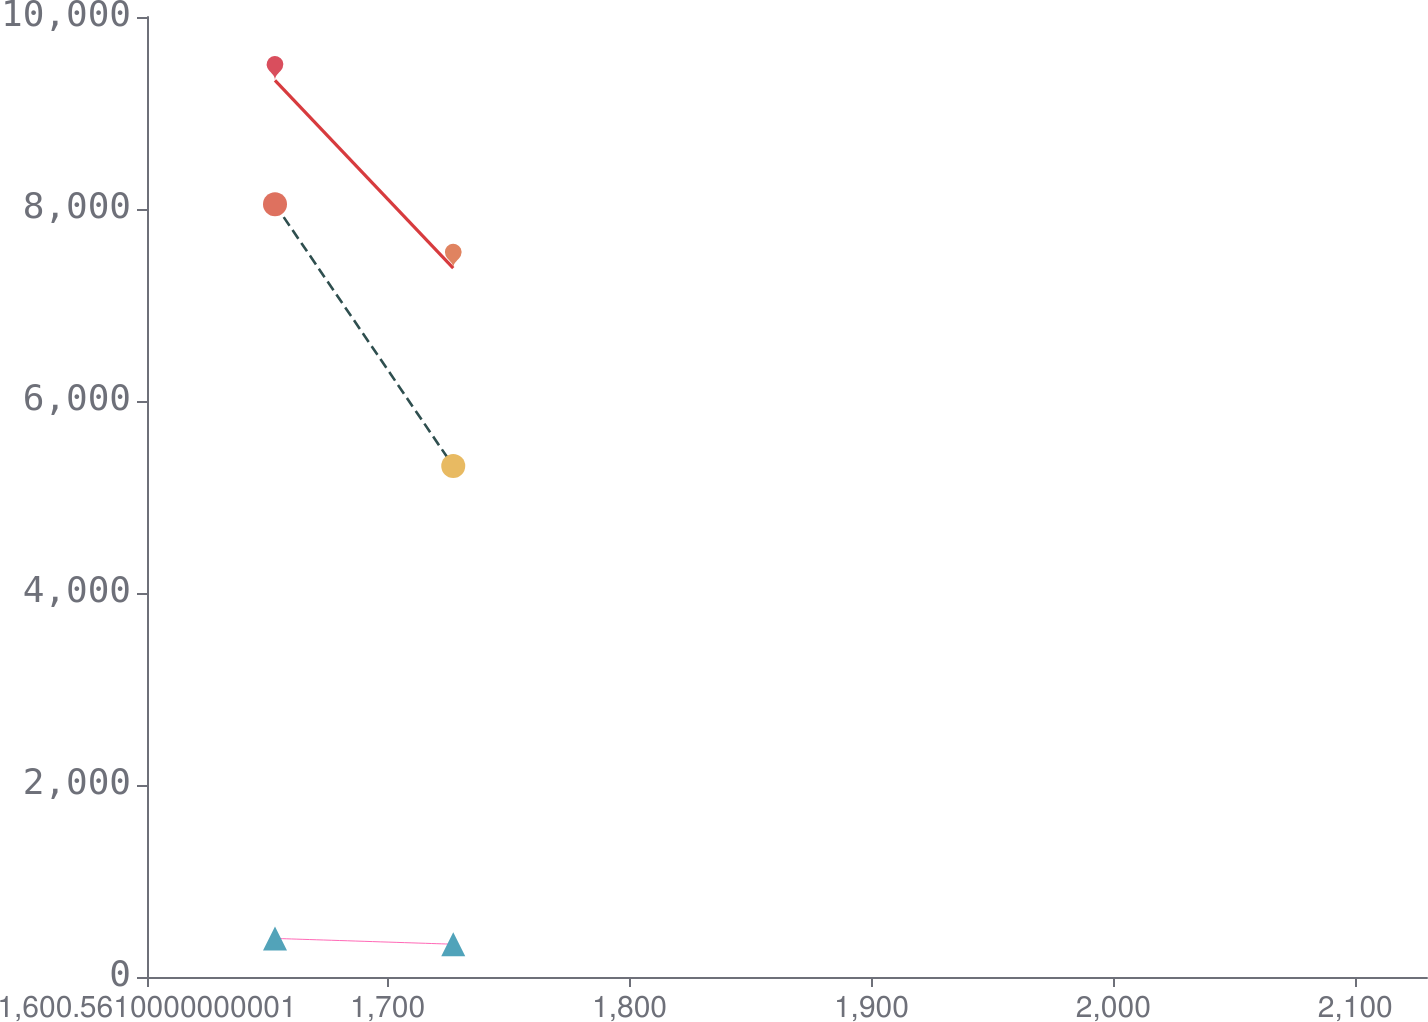Convert chart. <chart><loc_0><loc_0><loc_500><loc_500><line_chart><ecel><fcel>Facilities<fcel>Total<fcel>Equipment<nl><fcel>1653.47<fcel>8048.47<fcel>401.81<fcel>9339.03<nl><fcel>1727.15<fcel>5322.37<fcel>341.52<fcel>7384.08<nl><fcel>2182.56<fcel>4895.95<fcel>377.82<fcel>6135.32<nl></chart> 